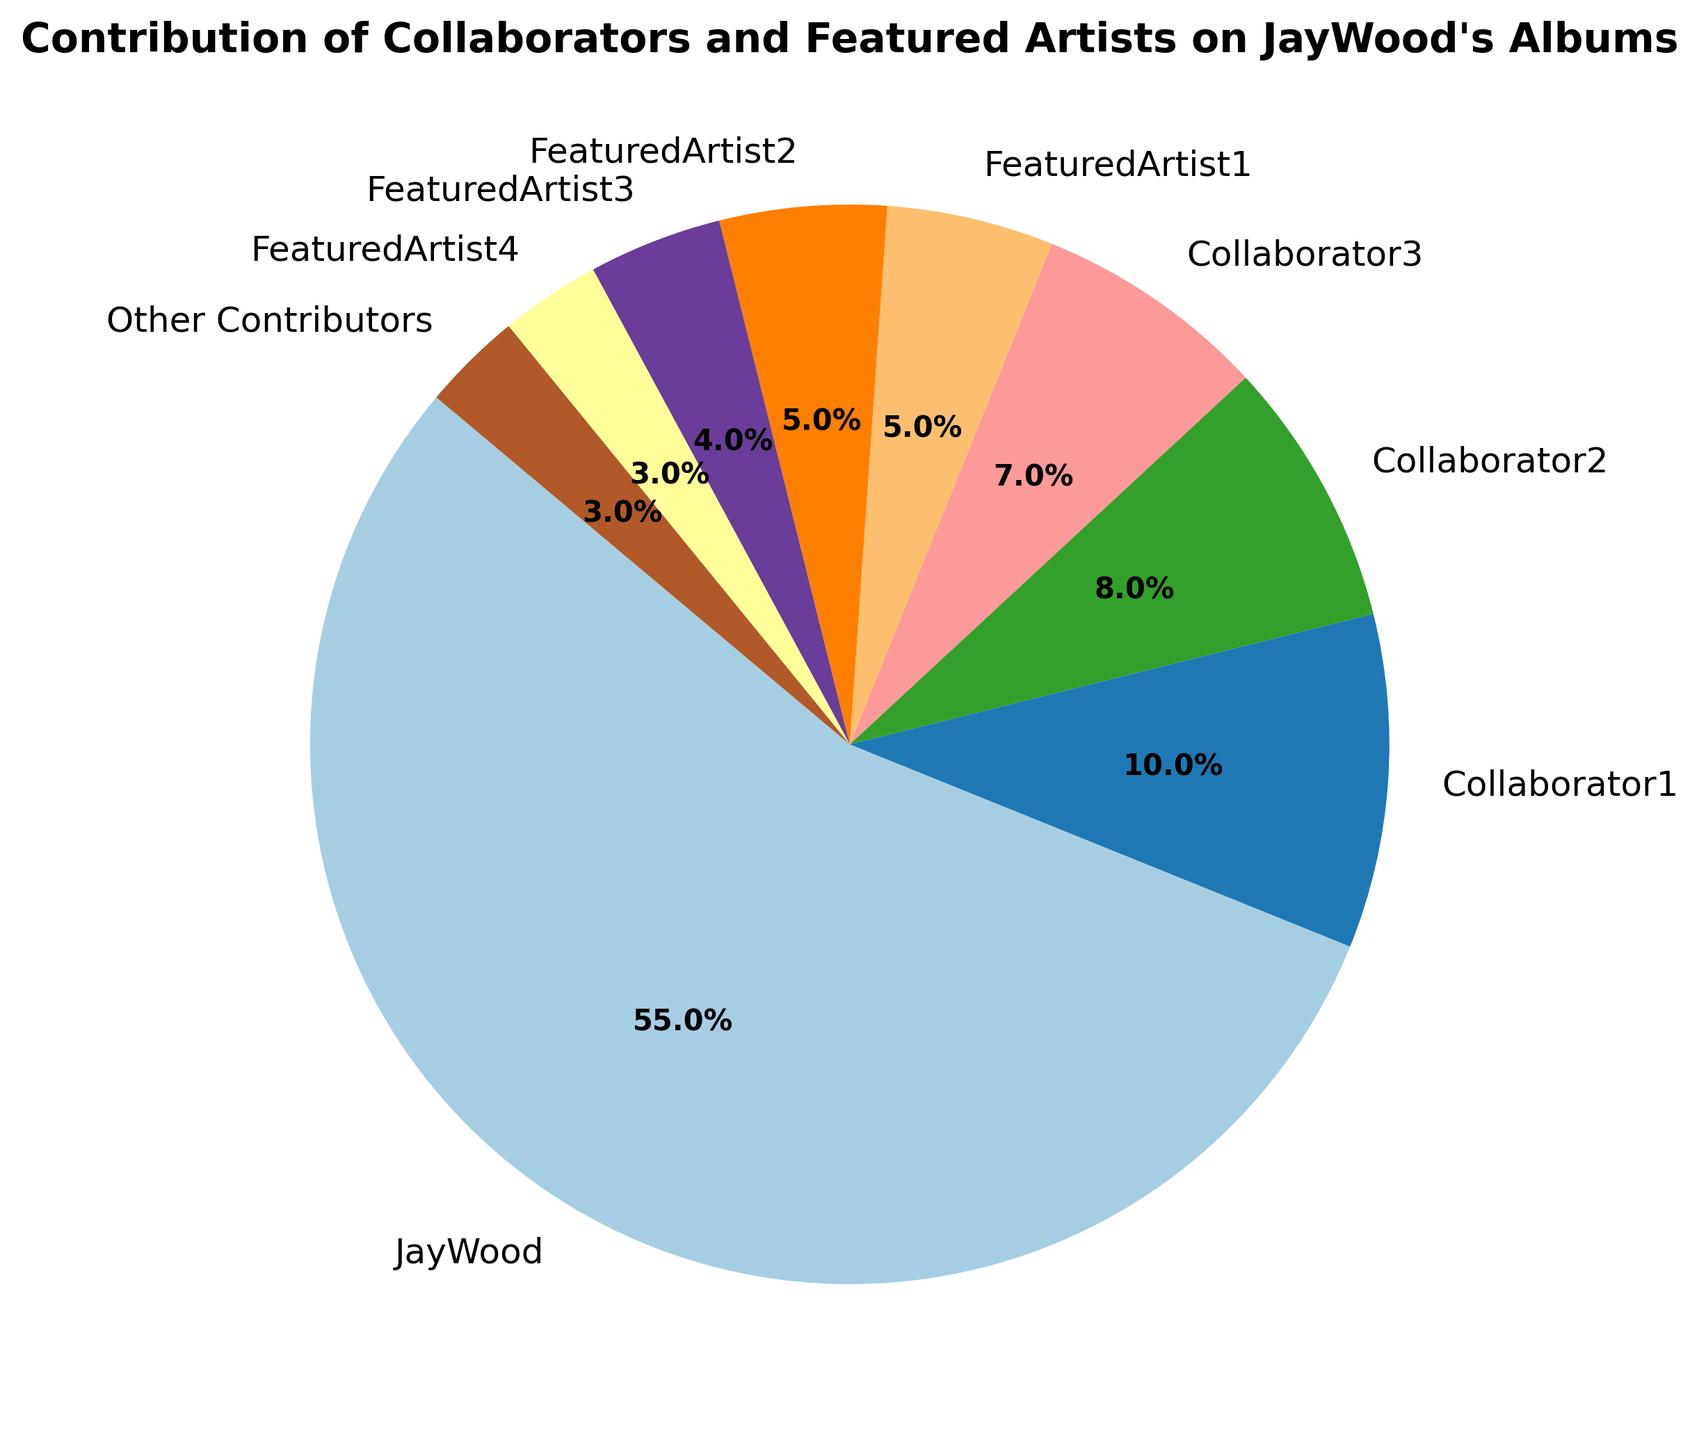What is the largest contribution percentage and who does it belong to? The figure shows the contribution percentages of various artists. The segment with the largest percentage is clearly labeled as "JayWood" with 55%.
Answer: JayWood with 55% What is the combined contribution percentage of Collaborator1, Collaborator2, and Collaborator3? To find the combined contribution percentage, add the percentages of Collaborator1, Collaborator2, and Collaborator3. These values are 10%, 8%, and 7%, respectively. Summing them up gives 10% + 8% + 7% = 25%.
Answer: 25% Which group has a smaller contribution, FeaturedArtist3 or FeaturedArtist4? The contribution percentage of FeaturedArtist3 is 4% and for FeaturedArtist4 is 3%. Comparing these values, 4% is greater than 3%, so FeaturedArtist4 has the smaller contribution.
Answer: FeaturedArtist4 What is the median contribution percentage among all artists? To find the median, list the percentages in order: 3%, 3%, 4%, 5%, 5%, 7%, 8%, 10%, 55%. The middle value (median) in this ordered list is the fifth value, which is 5%.
Answer: 5% Who contributes more, JayWood or the combined total of all FeaturedArtists? JayWood’s contribution is 55%. The total contribution of all FeaturedArtists is the sum of FeaturedArtist1 (5%), FeaturedArtist2 (5%), FeaturedArtist3 (4%), and FeaturedArtist4 (3%), which adds up to 5% + 5% + 4% + 3% = 17%. Comparing these, 55% is greater than 17%, so JayWood contributes more.
Answer: JayWood What percentage do Other Contributors account for? The percentage for Other Contributors is explicitly labeled in the figure as 3%.
Answer: 3% How many artists have contributions of 5% or less? The figure shows percentages for various artists. The artists with contributions of 5% or less are FeaturedArtist1 (5%), FeaturedArtist2 (5%), FeaturedArtist3 (4%), FeaturedArtist4 (3%), and Other Contributors (3%). There are five such artists in total.
Answer: 5 What is the difference in contribution percentage between Collaborator2 and Other Contributors? The contribution percentage for Collaborator2 is 8%, and for Other Contributors, it is 3%. The difference is 8% - 3% = 5%.
Answer: 5% If you combine the contributions of Collaborator2 and Collaborator3, do they contribute more than JayWood? Collaborator2's contribution is 8% and Collaborator3's is 7%, summing to 8% + 7% = 15%. JayWood's contribution is 55%. Since 15% is less than 55%, the combined contributions of Collaborator2 and Collaborator3 are less than JayWood’s contribution.
Answer: No 